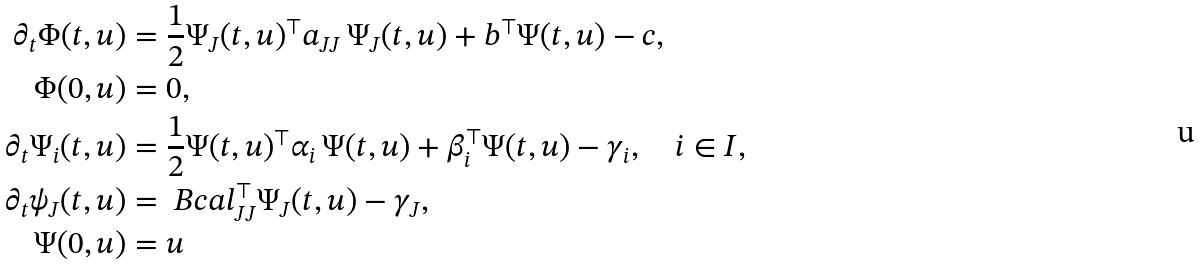Convert formula to latex. <formula><loc_0><loc_0><loc_500><loc_500>\partial _ { t } \Phi ( t , u ) & = \frac { 1 } { 2 } \Psi _ { J } ( t , u ) ^ { \top } a _ { J J } \, \Psi _ { J } ( t , u ) + b ^ { \top } \Psi ( t , u ) - c , \\ \Phi ( 0 , u ) & = 0 , \\ \partial _ { t } \Psi _ { i } ( t , u ) & = \frac { 1 } { 2 } \Psi ( t , u ) ^ { \top } \alpha _ { i } \, \Psi ( t , u ) + \beta _ { i } ^ { \top } \Psi ( t , u ) - \gamma _ { i } , \quad i \in I , \\ \partial _ { t } \psi _ { J } ( t , u ) & = \ B c a l _ { { J } { J } } ^ { \top } \Psi _ { J } ( t , u ) - \gamma _ { J } , \\ \Psi ( 0 , u ) & = u</formula> 